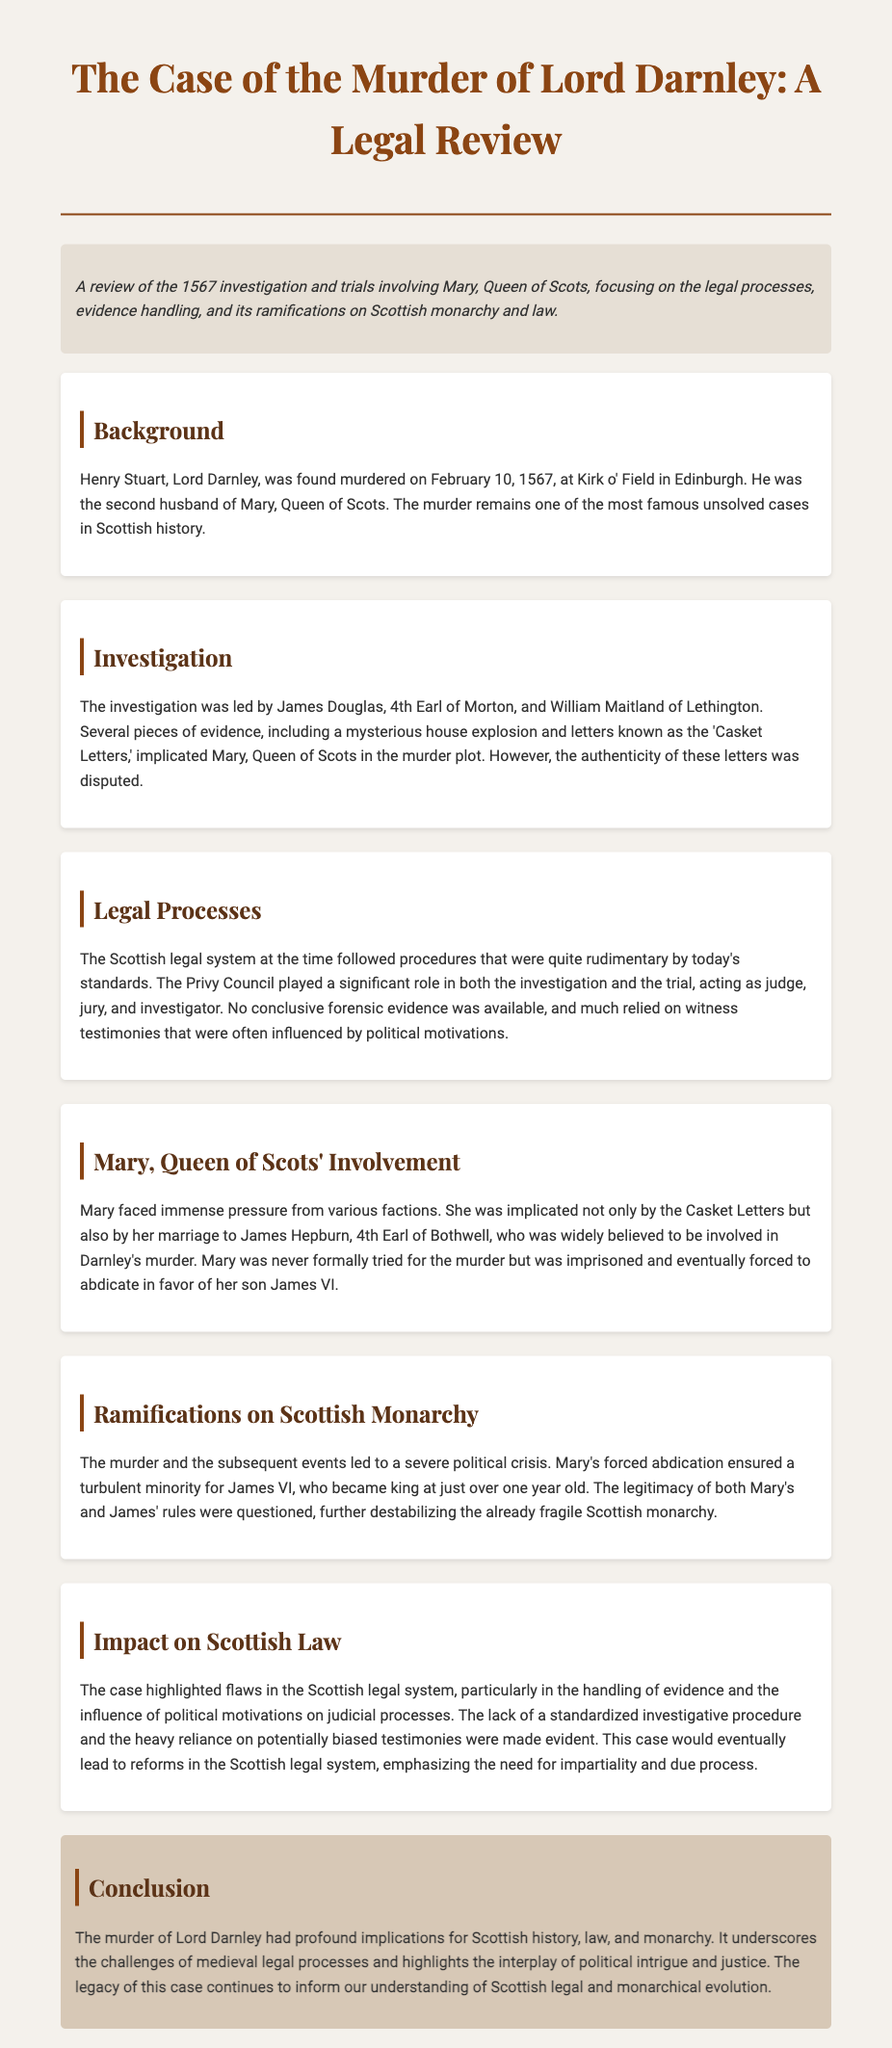What was the date of Lord Darnley's murder? The murder occurred on February 10, 1567, as stated in the background section of the document.
Answer: February 10, 1567 Who led the investigation into Lord Darnley's murder? The investigation was led by James Douglas, 4th Earl of Morton, and William Maitland of Lethington, as mentioned in the investigation section.
Answer: James Douglas, 4th Earl of Morton, and William Maitland of Lethington What significant evidence was disputed during the investigation? The authenticity of the letters known as the 'Casket Letters' was disputed, as detailed in the investigation section.
Answer: 'Casket Letters' What was one criticism of the Scottish legal system highlighted by the case? The case illustrated flaws in evidence handling and the influence of political motivations on judicial processes, as explained in the impact section.
Answer: Evidence handling What was the outcome for Mary, Queen of Scots after the murder investigation? Mary was imprisoned and eventually forced to abdicate in favor of her son James VI, as stated in her involvement section.
Answer: Imprisoned and forced to abdicate 